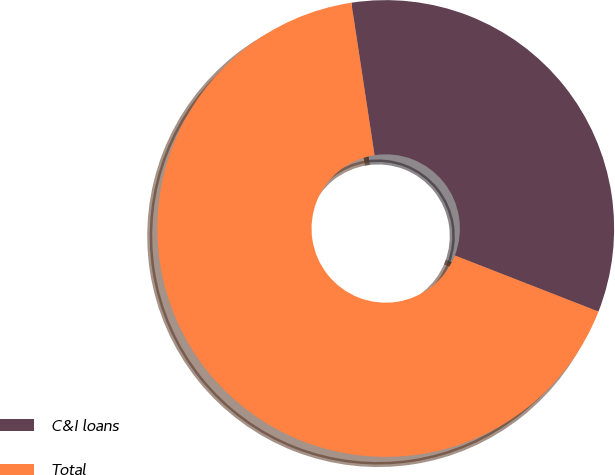Convert chart to OTSL. <chart><loc_0><loc_0><loc_500><loc_500><pie_chart><fcel>C&I loans<fcel>Total<nl><fcel>33.33%<fcel>66.67%<nl></chart> 